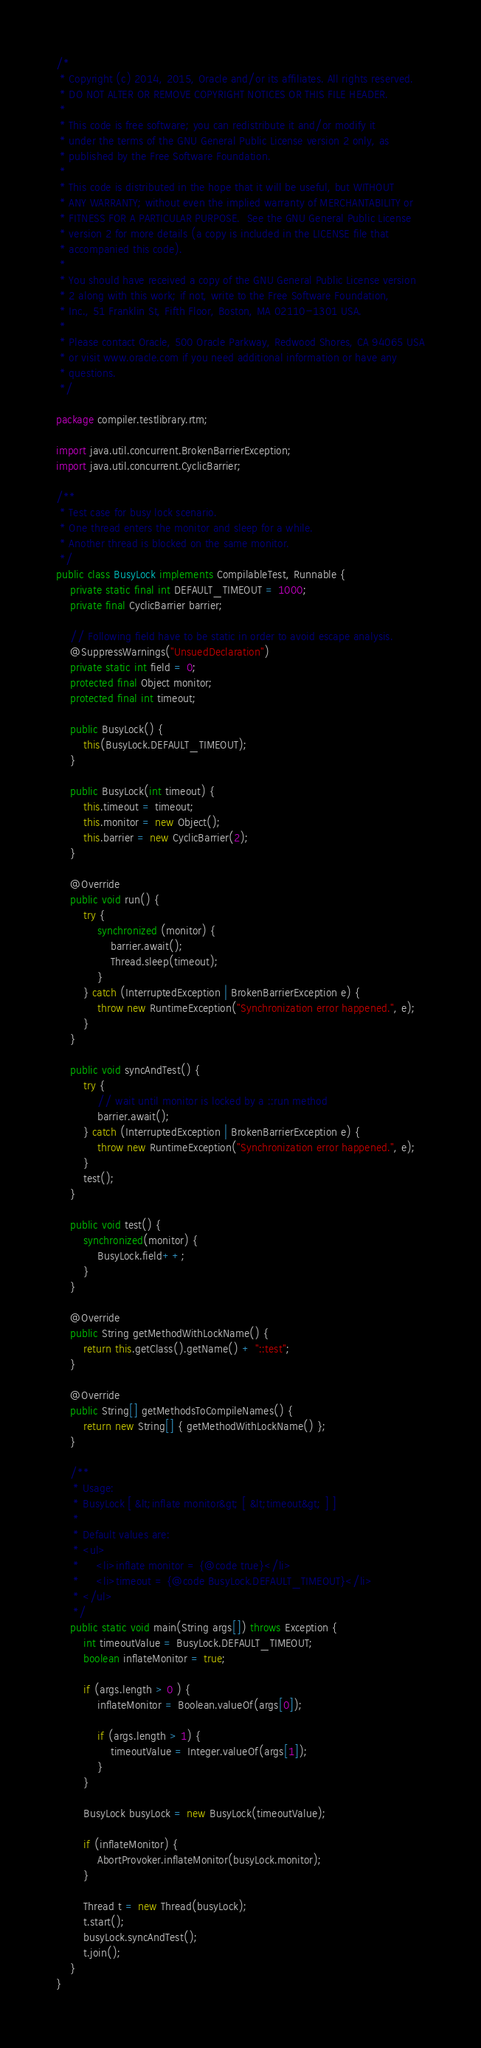Convert code to text. <code><loc_0><loc_0><loc_500><loc_500><_Java_>/*
 * Copyright (c) 2014, 2015, Oracle and/or its affiliates. All rights reserved.
 * DO NOT ALTER OR REMOVE COPYRIGHT NOTICES OR THIS FILE HEADER.
 *
 * This code is free software; you can redistribute it and/or modify it
 * under the terms of the GNU General Public License version 2 only, as
 * published by the Free Software Foundation.
 *
 * This code is distributed in the hope that it will be useful, but WITHOUT
 * ANY WARRANTY; without even the implied warranty of MERCHANTABILITY or
 * FITNESS FOR A PARTICULAR PURPOSE.  See the GNU General Public License
 * version 2 for more details (a copy is included in the LICENSE file that
 * accompanied this code).
 *
 * You should have received a copy of the GNU General Public License version
 * 2 along with this work; if not, write to the Free Software Foundation,
 * Inc., 51 Franklin St, Fifth Floor, Boston, MA 02110-1301 USA.
 *
 * Please contact Oracle, 500 Oracle Parkway, Redwood Shores, CA 94065 USA
 * or visit www.oracle.com if you need additional information or have any
 * questions.
 */

package compiler.testlibrary.rtm;

import java.util.concurrent.BrokenBarrierException;
import java.util.concurrent.CyclicBarrier;

/**
 * Test case for busy lock scenario.
 * One thread enters the monitor and sleep for a while.
 * Another thread is blocked on the same monitor.
 */
public class BusyLock implements CompilableTest, Runnable {
    private static final int DEFAULT_TIMEOUT = 1000;
    private final CyclicBarrier barrier;

    // Following field have to be static in order to avoid escape analysis.
    @SuppressWarnings("UnsuedDeclaration")
    private static int field = 0;
    protected final Object monitor;
    protected final int timeout;

    public BusyLock() {
        this(BusyLock.DEFAULT_TIMEOUT);
    }

    public BusyLock(int timeout) {
        this.timeout = timeout;
        this.monitor = new Object();
        this.barrier = new CyclicBarrier(2);
    }

    @Override
    public void run() {
        try {
            synchronized (monitor) {
                barrier.await();
                Thread.sleep(timeout);
            }
        } catch (InterruptedException | BrokenBarrierException e) {
            throw new RuntimeException("Synchronization error happened.", e);
        }
    }

    public void syncAndTest() {
        try {
            // wait until monitor is locked by a ::run method
            barrier.await();
        } catch (InterruptedException | BrokenBarrierException e) {
            throw new RuntimeException("Synchronization error happened.", e);
        }
        test();
    }

    public void test() {
        synchronized(monitor) {
            BusyLock.field++;
        }
    }

    @Override
    public String getMethodWithLockName() {
        return this.getClass().getName() + "::test";
    }

    @Override
    public String[] getMethodsToCompileNames() {
        return new String[] { getMethodWithLockName() };
    }

    /**
     * Usage:
     * BusyLock [ &lt;inflate monitor&gt; [ &lt;timeout&gt; ] ]
     *
     * Default values are:
     * <ul>
     *     <li>inflate monitor = {@code true}</li>
     *     <li>timeout = {@code BusyLock.DEFAULT_TIMEOUT}</li>
     * </ul>
     */
    public static void main(String args[]) throws Exception {
        int timeoutValue = BusyLock.DEFAULT_TIMEOUT;
        boolean inflateMonitor = true;

        if (args.length > 0 ) {
            inflateMonitor = Boolean.valueOf(args[0]);

            if (args.length > 1) {
                timeoutValue = Integer.valueOf(args[1]);
            }
        }

        BusyLock busyLock = new BusyLock(timeoutValue);

        if (inflateMonitor) {
            AbortProvoker.inflateMonitor(busyLock.monitor);
        }

        Thread t = new Thread(busyLock);
        t.start();
        busyLock.syncAndTest();
        t.join();
    }
}
</code> 